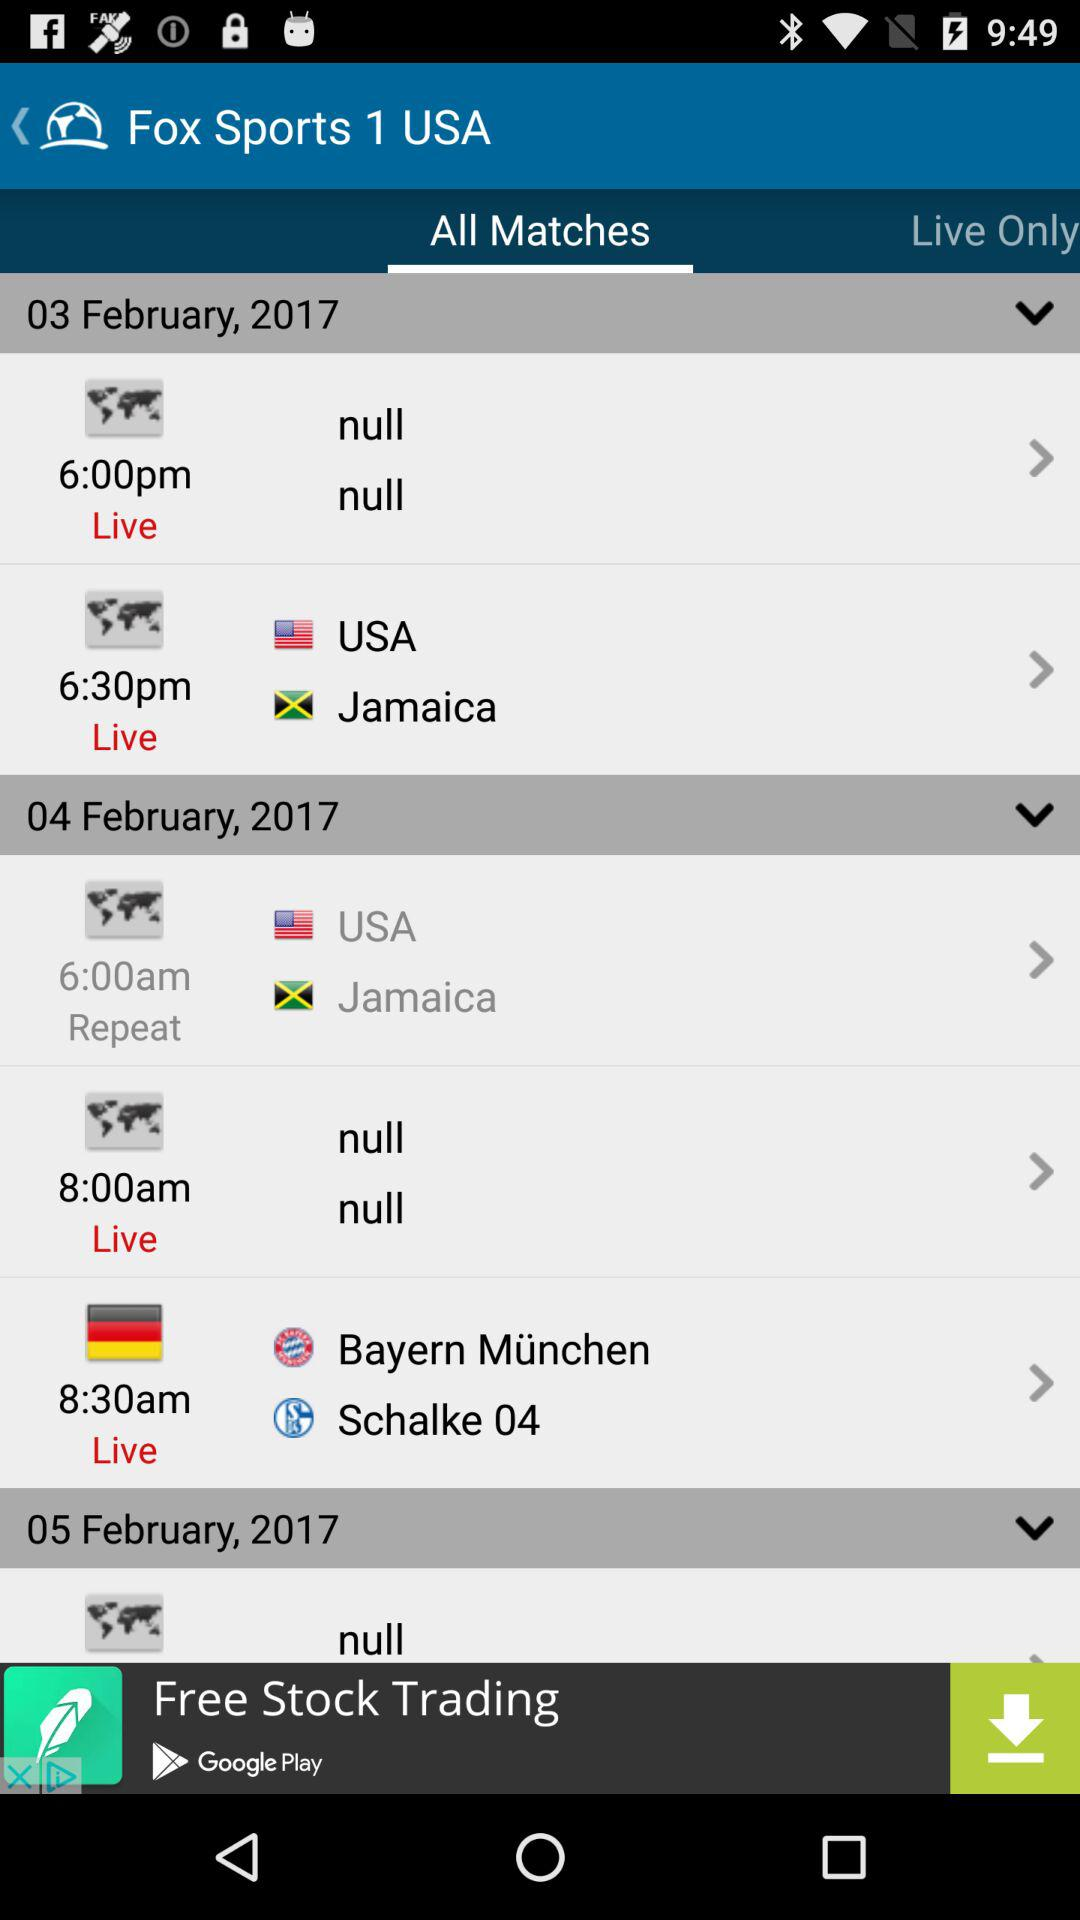Which teams have played matches on the 4th of February? The teams that have played matches on the 4th of February are "USA", "Jamaica", "Bayern München" and "Schalke 04". 